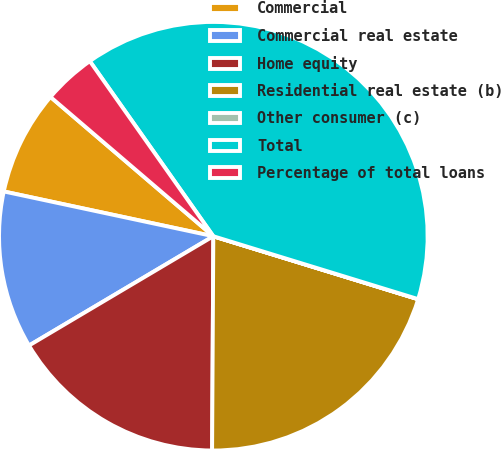Convert chart to OTSL. <chart><loc_0><loc_0><loc_500><loc_500><pie_chart><fcel>Commercial<fcel>Commercial real estate<fcel>Home equity<fcel>Residential real estate (b)<fcel>Other consumer (c)<fcel>Total<fcel>Percentage of total loans<nl><fcel>7.91%<fcel>11.87%<fcel>16.39%<fcel>20.34%<fcel>0.01%<fcel>39.52%<fcel>3.96%<nl></chart> 